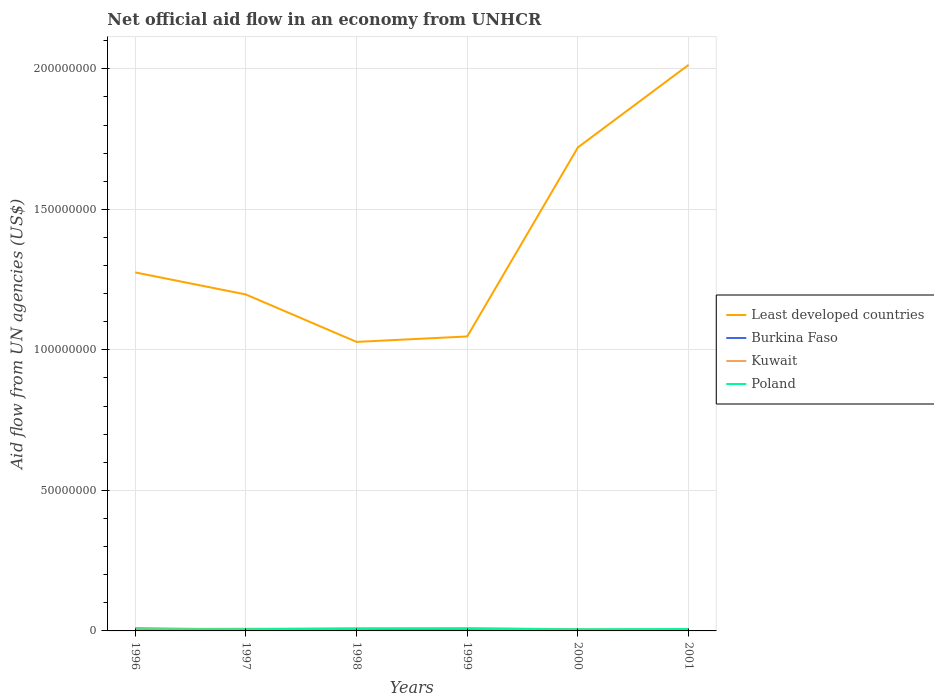Does the line corresponding to Least developed countries intersect with the line corresponding to Poland?
Provide a short and direct response. No. Across all years, what is the maximum net official aid flow in Kuwait?
Your response must be concise. 4.30e+05. In which year was the net official aid flow in Burkina Faso maximum?
Provide a succinct answer. 2000. What is the difference between the highest and the second highest net official aid flow in Kuwait?
Your answer should be very brief. 5.90e+05. What is the difference between the highest and the lowest net official aid flow in Burkina Faso?
Provide a short and direct response. 2. Is the net official aid flow in Kuwait strictly greater than the net official aid flow in Least developed countries over the years?
Give a very brief answer. Yes. How many lines are there?
Make the answer very short. 4. How many years are there in the graph?
Offer a terse response. 6. Does the graph contain any zero values?
Your answer should be very brief. No. Does the graph contain grids?
Provide a succinct answer. Yes. Where does the legend appear in the graph?
Your answer should be very brief. Center right. How are the legend labels stacked?
Offer a terse response. Vertical. What is the title of the graph?
Keep it short and to the point. Net official aid flow in an economy from UNHCR. Does "Syrian Arab Republic" appear as one of the legend labels in the graph?
Your answer should be very brief. No. What is the label or title of the X-axis?
Offer a terse response. Years. What is the label or title of the Y-axis?
Give a very brief answer. Aid flow from UN agencies (US$). What is the Aid flow from UN agencies (US$) in Least developed countries in 1996?
Your answer should be very brief. 1.28e+08. What is the Aid flow from UN agencies (US$) in Burkina Faso in 1996?
Make the answer very short. 9.00e+05. What is the Aid flow from UN agencies (US$) of Kuwait in 1996?
Provide a succinct answer. 6.90e+05. What is the Aid flow from UN agencies (US$) of Poland in 1996?
Offer a terse response. 5.40e+05. What is the Aid flow from UN agencies (US$) in Least developed countries in 1997?
Keep it short and to the point. 1.20e+08. What is the Aid flow from UN agencies (US$) in Burkina Faso in 1997?
Your response must be concise. 5.10e+05. What is the Aid flow from UN agencies (US$) in Kuwait in 1997?
Provide a succinct answer. 7.80e+05. What is the Aid flow from UN agencies (US$) in Poland in 1997?
Your answer should be very brief. 5.90e+05. What is the Aid flow from UN agencies (US$) in Least developed countries in 1998?
Keep it short and to the point. 1.03e+08. What is the Aid flow from UN agencies (US$) of Burkina Faso in 1998?
Your response must be concise. 3.80e+05. What is the Aid flow from UN agencies (US$) in Kuwait in 1998?
Give a very brief answer. 8.10e+05. What is the Aid flow from UN agencies (US$) in Poland in 1998?
Your answer should be compact. 9.20e+05. What is the Aid flow from UN agencies (US$) of Least developed countries in 1999?
Your answer should be compact. 1.05e+08. What is the Aid flow from UN agencies (US$) of Kuwait in 1999?
Your answer should be compact. 1.02e+06. What is the Aid flow from UN agencies (US$) of Poland in 1999?
Your response must be concise. 8.20e+05. What is the Aid flow from UN agencies (US$) in Least developed countries in 2000?
Ensure brevity in your answer.  1.72e+08. What is the Aid flow from UN agencies (US$) in Kuwait in 2000?
Provide a short and direct response. 5.80e+05. What is the Aid flow from UN agencies (US$) of Poland in 2000?
Your answer should be very brief. 5.70e+05. What is the Aid flow from UN agencies (US$) in Least developed countries in 2001?
Offer a terse response. 2.01e+08. What is the Aid flow from UN agencies (US$) in Kuwait in 2001?
Your answer should be very brief. 4.30e+05. What is the Aid flow from UN agencies (US$) in Poland in 2001?
Give a very brief answer. 6.80e+05. Across all years, what is the maximum Aid flow from UN agencies (US$) of Least developed countries?
Provide a short and direct response. 2.01e+08. Across all years, what is the maximum Aid flow from UN agencies (US$) in Kuwait?
Your answer should be very brief. 1.02e+06. Across all years, what is the maximum Aid flow from UN agencies (US$) in Poland?
Make the answer very short. 9.20e+05. Across all years, what is the minimum Aid flow from UN agencies (US$) in Least developed countries?
Your response must be concise. 1.03e+08. Across all years, what is the minimum Aid flow from UN agencies (US$) of Poland?
Make the answer very short. 5.40e+05. What is the total Aid flow from UN agencies (US$) of Least developed countries in the graph?
Your answer should be compact. 8.28e+08. What is the total Aid flow from UN agencies (US$) of Burkina Faso in the graph?
Your response must be concise. 2.54e+06. What is the total Aid flow from UN agencies (US$) of Kuwait in the graph?
Your answer should be very brief. 4.31e+06. What is the total Aid flow from UN agencies (US$) of Poland in the graph?
Make the answer very short. 4.12e+06. What is the difference between the Aid flow from UN agencies (US$) of Least developed countries in 1996 and that in 1997?
Your answer should be very brief. 7.85e+06. What is the difference between the Aid flow from UN agencies (US$) in Kuwait in 1996 and that in 1997?
Offer a very short reply. -9.00e+04. What is the difference between the Aid flow from UN agencies (US$) in Poland in 1996 and that in 1997?
Provide a succinct answer. -5.00e+04. What is the difference between the Aid flow from UN agencies (US$) in Least developed countries in 1996 and that in 1998?
Your response must be concise. 2.47e+07. What is the difference between the Aid flow from UN agencies (US$) in Burkina Faso in 1996 and that in 1998?
Ensure brevity in your answer.  5.20e+05. What is the difference between the Aid flow from UN agencies (US$) in Kuwait in 1996 and that in 1998?
Your response must be concise. -1.20e+05. What is the difference between the Aid flow from UN agencies (US$) of Poland in 1996 and that in 1998?
Make the answer very short. -3.80e+05. What is the difference between the Aid flow from UN agencies (US$) in Least developed countries in 1996 and that in 1999?
Offer a terse response. 2.28e+07. What is the difference between the Aid flow from UN agencies (US$) in Burkina Faso in 1996 and that in 1999?
Ensure brevity in your answer.  6.40e+05. What is the difference between the Aid flow from UN agencies (US$) of Kuwait in 1996 and that in 1999?
Provide a short and direct response. -3.30e+05. What is the difference between the Aid flow from UN agencies (US$) in Poland in 1996 and that in 1999?
Provide a succinct answer. -2.80e+05. What is the difference between the Aid flow from UN agencies (US$) in Least developed countries in 1996 and that in 2000?
Provide a short and direct response. -4.45e+07. What is the difference between the Aid flow from UN agencies (US$) in Burkina Faso in 1996 and that in 2000?
Make the answer very short. 7.00e+05. What is the difference between the Aid flow from UN agencies (US$) in Kuwait in 1996 and that in 2000?
Your answer should be compact. 1.10e+05. What is the difference between the Aid flow from UN agencies (US$) of Poland in 1996 and that in 2000?
Offer a very short reply. -3.00e+04. What is the difference between the Aid flow from UN agencies (US$) of Least developed countries in 1996 and that in 2001?
Provide a short and direct response. -7.38e+07. What is the difference between the Aid flow from UN agencies (US$) of Burkina Faso in 1996 and that in 2001?
Your response must be concise. 6.10e+05. What is the difference between the Aid flow from UN agencies (US$) of Least developed countries in 1997 and that in 1998?
Your answer should be compact. 1.69e+07. What is the difference between the Aid flow from UN agencies (US$) in Burkina Faso in 1997 and that in 1998?
Provide a succinct answer. 1.30e+05. What is the difference between the Aid flow from UN agencies (US$) in Poland in 1997 and that in 1998?
Offer a terse response. -3.30e+05. What is the difference between the Aid flow from UN agencies (US$) of Least developed countries in 1997 and that in 1999?
Your answer should be compact. 1.49e+07. What is the difference between the Aid flow from UN agencies (US$) of Burkina Faso in 1997 and that in 1999?
Offer a terse response. 2.50e+05. What is the difference between the Aid flow from UN agencies (US$) in Least developed countries in 1997 and that in 2000?
Your response must be concise. -5.23e+07. What is the difference between the Aid flow from UN agencies (US$) in Kuwait in 1997 and that in 2000?
Offer a very short reply. 2.00e+05. What is the difference between the Aid flow from UN agencies (US$) of Poland in 1997 and that in 2000?
Your response must be concise. 2.00e+04. What is the difference between the Aid flow from UN agencies (US$) in Least developed countries in 1997 and that in 2001?
Your answer should be very brief. -8.17e+07. What is the difference between the Aid flow from UN agencies (US$) in Poland in 1997 and that in 2001?
Ensure brevity in your answer.  -9.00e+04. What is the difference between the Aid flow from UN agencies (US$) in Least developed countries in 1998 and that in 1999?
Ensure brevity in your answer.  -1.93e+06. What is the difference between the Aid flow from UN agencies (US$) of Least developed countries in 1998 and that in 2000?
Provide a succinct answer. -6.92e+07. What is the difference between the Aid flow from UN agencies (US$) of Burkina Faso in 1998 and that in 2000?
Your answer should be very brief. 1.80e+05. What is the difference between the Aid flow from UN agencies (US$) in Poland in 1998 and that in 2000?
Ensure brevity in your answer.  3.50e+05. What is the difference between the Aid flow from UN agencies (US$) of Least developed countries in 1998 and that in 2001?
Offer a terse response. -9.86e+07. What is the difference between the Aid flow from UN agencies (US$) of Least developed countries in 1999 and that in 2000?
Offer a terse response. -6.73e+07. What is the difference between the Aid flow from UN agencies (US$) in Least developed countries in 1999 and that in 2001?
Your response must be concise. -9.66e+07. What is the difference between the Aid flow from UN agencies (US$) of Kuwait in 1999 and that in 2001?
Provide a short and direct response. 5.90e+05. What is the difference between the Aid flow from UN agencies (US$) of Poland in 1999 and that in 2001?
Keep it short and to the point. 1.40e+05. What is the difference between the Aid flow from UN agencies (US$) of Least developed countries in 2000 and that in 2001?
Your response must be concise. -2.94e+07. What is the difference between the Aid flow from UN agencies (US$) of Burkina Faso in 2000 and that in 2001?
Offer a very short reply. -9.00e+04. What is the difference between the Aid flow from UN agencies (US$) of Kuwait in 2000 and that in 2001?
Ensure brevity in your answer.  1.50e+05. What is the difference between the Aid flow from UN agencies (US$) in Poland in 2000 and that in 2001?
Ensure brevity in your answer.  -1.10e+05. What is the difference between the Aid flow from UN agencies (US$) of Least developed countries in 1996 and the Aid flow from UN agencies (US$) of Burkina Faso in 1997?
Make the answer very short. 1.27e+08. What is the difference between the Aid flow from UN agencies (US$) in Least developed countries in 1996 and the Aid flow from UN agencies (US$) in Kuwait in 1997?
Your answer should be compact. 1.27e+08. What is the difference between the Aid flow from UN agencies (US$) in Least developed countries in 1996 and the Aid flow from UN agencies (US$) in Poland in 1997?
Offer a terse response. 1.27e+08. What is the difference between the Aid flow from UN agencies (US$) in Burkina Faso in 1996 and the Aid flow from UN agencies (US$) in Kuwait in 1997?
Keep it short and to the point. 1.20e+05. What is the difference between the Aid flow from UN agencies (US$) in Burkina Faso in 1996 and the Aid flow from UN agencies (US$) in Poland in 1997?
Provide a succinct answer. 3.10e+05. What is the difference between the Aid flow from UN agencies (US$) in Least developed countries in 1996 and the Aid flow from UN agencies (US$) in Burkina Faso in 1998?
Provide a short and direct response. 1.27e+08. What is the difference between the Aid flow from UN agencies (US$) of Least developed countries in 1996 and the Aid flow from UN agencies (US$) of Kuwait in 1998?
Your answer should be compact. 1.27e+08. What is the difference between the Aid flow from UN agencies (US$) of Least developed countries in 1996 and the Aid flow from UN agencies (US$) of Poland in 1998?
Your answer should be very brief. 1.27e+08. What is the difference between the Aid flow from UN agencies (US$) in Burkina Faso in 1996 and the Aid flow from UN agencies (US$) in Kuwait in 1998?
Give a very brief answer. 9.00e+04. What is the difference between the Aid flow from UN agencies (US$) in Kuwait in 1996 and the Aid flow from UN agencies (US$) in Poland in 1998?
Provide a short and direct response. -2.30e+05. What is the difference between the Aid flow from UN agencies (US$) of Least developed countries in 1996 and the Aid flow from UN agencies (US$) of Burkina Faso in 1999?
Provide a succinct answer. 1.27e+08. What is the difference between the Aid flow from UN agencies (US$) in Least developed countries in 1996 and the Aid flow from UN agencies (US$) in Kuwait in 1999?
Keep it short and to the point. 1.27e+08. What is the difference between the Aid flow from UN agencies (US$) in Least developed countries in 1996 and the Aid flow from UN agencies (US$) in Poland in 1999?
Your answer should be compact. 1.27e+08. What is the difference between the Aid flow from UN agencies (US$) of Burkina Faso in 1996 and the Aid flow from UN agencies (US$) of Kuwait in 1999?
Offer a terse response. -1.20e+05. What is the difference between the Aid flow from UN agencies (US$) in Least developed countries in 1996 and the Aid flow from UN agencies (US$) in Burkina Faso in 2000?
Provide a succinct answer. 1.27e+08. What is the difference between the Aid flow from UN agencies (US$) of Least developed countries in 1996 and the Aid flow from UN agencies (US$) of Kuwait in 2000?
Provide a short and direct response. 1.27e+08. What is the difference between the Aid flow from UN agencies (US$) of Least developed countries in 1996 and the Aid flow from UN agencies (US$) of Poland in 2000?
Offer a terse response. 1.27e+08. What is the difference between the Aid flow from UN agencies (US$) of Burkina Faso in 1996 and the Aid flow from UN agencies (US$) of Kuwait in 2000?
Provide a succinct answer. 3.20e+05. What is the difference between the Aid flow from UN agencies (US$) in Burkina Faso in 1996 and the Aid flow from UN agencies (US$) in Poland in 2000?
Provide a short and direct response. 3.30e+05. What is the difference between the Aid flow from UN agencies (US$) of Least developed countries in 1996 and the Aid flow from UN agencies (US$) of Burkina Faso in 2001?
Your answer should be compact. 1.27e+08. What is the difference between the Aid flow from UN agencies (US$) of Least developed countries in 1996 and the Aid flow from UN agencies (US$) of Kuwait in 2001?
Make the answer very short. 1.27e+08. What is the difference between the Aid flow from UN agencies (US$) in Least developed countries in 1996 and the Aid flow from UN agencies (US$) in Poland in 2001?
Ensure brevity in your answer.  1.27e+08. What is the difference between the Aid flow from UN agencies (US$) in Least developed countries in 1997 and the Aid flow from UN agencies (US$) in Burkina Faso in 1998?
Your answer should be very brief. 1.19e+08. What is the difference between the Aid flow from UN agencies (US$) of Least developed countries in 1997 and the Aid flow from UN agencies (US$) of Kuwait in 1998?
Provide a short and direct response. 1.19e+08. What is the difference between the Aid flow from UN agencies (US$) of Least developed countries in 1997 and the Aid flow from UN agencies (US$) of Poland in 1998?
Offer a very short reply. 1.19e+08. What is the difference between the Aid flow from UN agencies (US$) of Burkina Faso in 1997 and the Aid flow from UN agencies (US$) of Poland in 1998?
Provide a short and direct response. -4.10e+05. What is the difference between the Aid flow from UN agencies (US$) in Least developed countries in 1997 and the Aid flow from UN agencies (US$) in Burkina Faso in 1999?
Provide a short and direct response. 1.19e+08. What is the difference between the Aid flow from UN agencies (US$) in Least developed countries in 1997 and the Aid flow from UN agencies (US$) in Kuwait in 1999?
Make the answer very short. 1.19e+08. What is the difference between the Aid flow from UN agencies (US$) of Least developed countries in 1997 and the Aid flow from UN agencies (US$) of Poland in 1999?
Provide a succinct answer. 1.19e+08. What is the difference between the Aid flow from UN agencies (US$) in Burkina Faso in 1997 and the Aid flow from UN agencies (US$) in Kuwait in 1999?
Make the answer very short. -5.10e+05. What is the difference between the Aid flow from UN agencies (US$) in Burkina Faso in 1997 and the Aid flow from UN agencies (US$) in Poland in 1999?
Offer a very short reply. -3.10e+05. What is the difference between the Aid flow from UN agencies (US$) of Kuwait in 1997 and the Aid flow from UN agencies (US$) of Poland in 1999?
Provide a succinct answer. -4.00e+04. What is the difference between the Aid flow from UN agencies (US$) in Least developed countries in 1997 and the Aid flow from UN agencies (US$) in Burkina Faso in 2000?
Provide a succinct answer. 1.20e+08. What is the difference between the Aid flow from UN agencies (US$) of Least developed countries in 1997 and the Aid flow from UN agencies (US$) of Kuwait in 2000?
Offer a very short reply. 1.19e+08. What is the difference between the Aid flow from UN agencies (US$) in Least developed countries in 1997 and the Aid flow from UN agencies (US$) in Poland in 2000?
Keep it short and to the point. 1.19e+08. What is the difference between the Aid flow from UN agencies (US$) in Least developed countries in 1997 and the Aid flow from UN agencies (US$) in Burkina Faso in 2001?
Offer a very short reply. 1.19e+08. What is the difference between the Aid flow from UN agencies (US$) in Least developed countries in 1997 and the Aid flow from UN agencies (US$) in Kuwait in 2001?
Ensure brevity in your answer.  1.19e+08. What is the difference between the Aid flow from UN agencies (US$) in Least developed countries in 1997 and the Aid flow from UN agencies (US$) in Poland in 2001?
Provide a short and direct response. 1.19e+08. What is the difference between the Aid flow from UN agencies (US$) in Burkina Faso in 1997 and the Aid flow from UN agencies (US$) in Kuwait in 2001?
Ensure brevity in your answer.  8.00e+04. What is the difference between the Aid flow from UN agencies (US$) in Least developed countries in 1998 and the Aid flow from UN agencies (US$) in Burkina Faso in 1999?
Provide a short and direct response. 1.03e+08. What is the difference between the Aid flow from UN agencies (US$) of Least developed countries in 1998 and the Aid flow from UN agencies (US$) of Kuwait in 1999?
Offer a very short reply. 1.02e+08. What is the difference between the Aid flow from UN agencies (US$) of Least developed countries in 1998 and the Aid flow from UN agencies (US$) of Poland in 1999?
Ensure brevity in your answer.  1.02e+08. What is the difference between the Aid flow from UN agencies (US$) in Burkina Faso in 1998 and the Aid flow from UN agencies (US$) in Kuwait in 1999?
Offer a terse response. -6.40e+05. What is the difference between the Aid flow from UN agencies (US$) in Burkina Faso in 1998 and the Aid flow from UN agencies (US$) in Poland in 1999?
Give a very brief answer. -4.40e+05. What is the difference between the Aid flow from UN agencies (US$) in Least developed countries in 1998 and the Aid flow from UN agencies (US$) in Burkina Faso in 2000?
Provide a short and direct response. 1.03e+08. What is the difference between the Aid flow from UN agencies (US$) in Least developed countries in 1998 and the Aid flow from UN agencies (US$) in Kuwait in 2000?
Your answer should be compact. 1.02e+08. What is the difference between the Aid flow from UN agencies (US$) in Least developed countries in 1998 and the Aid flow from UN agencies (US$) in Poland in 2000?
Provide a short and direct response. 1.02e+08. What is the difference between the Aid flow from UN agencies (US$) in Burkina Faso in 1998 and the Aid flow from UN agencies (US$) in Kuwait in 2000?
Your response must be concise. -2.00e+05. What is the difference between the Aid flow from UN agencies (US$) of Kuwait in 1998 and the Aid flow from UN agencies (US$) of Poland in 2000?
Offer a terse response. 2.40e+05. What is the difference between the Aid flow from UN agencies (US$) in Least developed countries in 1998 and the Aid flow from UN agencies (US$) in Burkina Faso in 2001?
Offer a terse response. 1.03e+08. What is the difference between the Aid flow from UN agencies (US$) in Least developed countries in 1998 and the Aid flow from UN agencies (US$) in Kuwait in 2001?
Your response must be concise. 1.02e+08. What is the difference between the Aid flow from UN agencies (US$) in Least developed countries in 1998 and the Aid flow from UN agencies (US$) in Poland in 2001?
Ensure brevity in your answer.  1.02e+08. What is the difference between the Aid flow from UN agencies (US$) in Least developed countries in 1999 and the Aid flow from UN agencies (US$) in Burkina Faso in 2000?
Ensure brevity in your answer.  1.05e+08. What is the difference between the Aid flow from UN agencies (US$) in Least developed countries in 1999 and the Aid flow from UN agencies (US$) in Kuwait in 2000?
Keep it short and to the point. 1.04e+08. What is the difference between the Aid flow from UN agencies (US$) of Least developed countries in 1999 and the Aid flow from UN agencies (US$) of Poland in 2000?
Give a very brief answer. 1.04e+08. What is the difference between the Aid flow from UN agencies (US$) of Burkina Faso in 1999 and the Aid flow from UN agencies (US$) of Kuwait in 2000?
Your answer should be very brief. -3.20e+05. What is the difference between the Aid flow from UN agencies (US$) in Burkina Faso in 1999 and the Aid flow from UN agencies (US$) in Poland in 2000?
Your answer should be compact. -3.10e+05. What is the difference between the Aid flow from UN agencies (US$) in Least developed countries in 1999 and the Aid flow from UN agencies (US$) in Burkina Faso in 2001?
Offer a terse response. 1.04e+08. What is the difference between the Aid flow from UN agencies (US$) of Least developed countries in 1999 and the Aid flow from UN agencies (US$) of Kuwait in 2001?
Your answer should be compact. 1.04e+08. What is the difference between the Aid flow from UN agencies (US$) of Least developed countries in 1999 and the Aid flow from UN agencies (US$) of Poland in 2001?
Offer a very short reply. 1.04e+08. What is the difference between the Aid flow from UN agencies (US$) of Burkina Faso in 1999 and the Aid flow from UN agencies (US$) of Kuwait in 2001?
Your response must be concise. -1.70e+05. What is the difference between the Aid flow from UN agencies (US$) in Burkina Faso in 1999 and the Aid flow from UN agencies (US$) in Poland in 2001?
Ensure brevity in your answer.  -4.20e+05. What is the difference between the Aid flow from UN agencies (US$) in Least developed countries in 2000 and the Aid flow from UN agencies (US$) in Burkina Faso in 2001?
Your response must be concise. 1.72e+08. What is the difference between the Aid flow from UN agencies (US$) in Least developed countries in 2000 and the Aid flow from UN agencies (US$) in Kuwait in 2001?
Your answer should be very brief. 1.72e+08. What is the difference between the Aid flow from UN agencies (US$) in Least developed countries in 2000 and the Aid flow from UN agencies (US$) in Poland in 2001?
Offer a terse response. 1.71e+08. What is the difference between the Aid flow from UN agencies (US$) in Burkina Faso in 2000 and the Aid flow from UN agencies (US$) in Poland in 2001?
Provide a short and direct response. -4.80e+05. What is the average Aid flow from UN agencies (US$) of Least developed countries per year?
Your answer should be very brief. 1.38e+08. What is the average Aid flow from UN agencies (US$) of Burkina Faso per year?
Your answer should be compact. 4.23e+05. What is the average Aid flow from UN agencies (US$) of Kuwait per year?
Provide a succinct answer. 7.18e+05. What is the average Aid flow from UN agencies (US$) in Poland per year?
Give a very brief answer. 6.87e+05. In the year 1996, what is the difference between the Aid flow from UN agencies (US$) in Least developed countries and Aid flow from UN agencies (US$) in Burkina Faso?
Make the answer very short. 1.27e+08. In the year 1996, what is the difference between the Aid flow from UN agencies (US$) in Least developed countries and Aid flow from UN agencies (US$) in Kuwait?
Keep it short and to the point. 1.27e+08. In the year 1996, what is the difference between the Aid flow from UN agencies (US$) in Least developed countries and Aid flow from UN agencies (US$) in Poland?
Provide a succinct answer. 1.27e+08. In the year 1997, what is the difference between the Aid flow from UN agencies (US$) in Least developed countries and Aid flow from UN agencies (US$) in Burkina Faso?
Your response must be concise. 1.19e+08. In the year 1997, what is the difference between the Aid flow from UN agencies (US$) of Least developed countries and Aid flow from UN agencies (US$) of Kuwait?
Offer a very short reply. 1.19e+08. In the year 1997, what is the difference between the Aid flow from UN agencies (US$) of Least developed countries and Aid flow from UN agencies (US$) of Poland?
Give a very brief answer. 1.19e+08. In the year 1998, what is the difference between the Aid flow from UN agencies (US$) of Least developed countries and Aid flow from UN agencies (US$) of Burkina Faso?
Provide a short and direct response. 1.02e+08. In the year 1998, what is the difference between the Aid flow from UN agencies (US$) in Least developed countries and Aid flow from UN agencies (US$) in Kuwait?
Provide a succinct answer. 1.02e+08. In the year 1998, what is the difference between the Aid flow from UN agencies (US$) in Least developed countries and Aid flow from UN agencies (US$) in Poland?
Make the answer very short. 1.02e+08. In the year 1998, what is the difference between the Aid flow from UN agencies (US$) in Burkina Faso and Aid flow from UN agencies (US$) in Kuwait?
Offer a very short reply. -4.30e+05. In the year 1998, what is the difference between the Aid flow from UN agencies (US$) in Burkina Faso and Aid flow from UN agencies (US$) in Poland?
Your response must be concise. -5.40e+05. In the year 1999, what is the difference between the Aid flow from UN agencies (US$) in Least developed countries and Aid flow from UN agencies (US$) in Burkina Faso?
Offer a terse response. 1.05e+08. In the year 1999, what is the difference between the Aid flow from UN agencies (US$) in Least developed countries and Aid flow from UN agencies (US$) in Kuwait?
Give a very brief answer. 1.04e+08. In the year 1999, what is the difference between the Aid flow from UN agencies (US$) in Least developed countries and Aid flow from UN agencies (US$) in Poland?
Offer a very short reply. 1.04e+08. In the year 1999, what is the difference between the Aid flow from UN agencies (US$) of Burkina Faso and Aid flow from UN agencies (US$) of Kuwait?
Offer a terse response. -7.60e+05. In the year 1999, what is the difference between the Aid flow from UN agencies (US$) of Burkina Faso and Aid flow from UN agencies (US$) of Poland?
Ensure brevity in your answer.  -5.60e+05. In the year 1999, what is the difference between the Aid flow from UN agencies (US$) of Kuwait and Aid flow from UN agencies (US$) of Poland?
Your response must be concise. 2.00e+05. In the year 2000, what is the difference between the Aid flow from UN agencies (US$) in Least developed countries and Aid flow from UN agencies (US$) in Burkina Faso?
Offer a very short reply. 1.72e+08. In the year 2000, what is the difference between the Aid flow from UN agencies (US$) in Least developed countries and Aid flow from UN agencies (US$) in Kuwait?
Offer a terse response. 1.71e+08. In the year 2000, what is the difference between the Aid flow from UN agencies (US$) of Least developed countries and Aid flow from UN agencies (US$) of Poland?
Give a very brief answer. 1.71e+08. In the year 2000, what is the difference between the Aid flow from UN agencies (US$) of Burkina Faso and Aid flow from UN agencies (US$) of Kuwait?
Make the answer very short. -3.80e+05. In the year 2000, what is the difference between the Aid flow from UN agencies (US$) in Burkina Faso and Aid flow from UN agencies (US$) in Poland?
Your response must be concise. -3.70e+05. In the year 2001, what is the difference between the Aid flow from UN agencies (US$) of Least developed countries and Aid flow from UN agencies (US$) of Burkina Faso?
Your answer should be very brief. 2.01e+08. In the year 2001, what is the difference between the Aid flow from UN agencies (US$) in Least developed countries and Aid flow from UN agencies (US$) in Kuwait?
Keep it short and to the point. 2.01e+08. In the year 2001, what is the difference between the Aid flow from UN agencies (US$) of Least developed countries and Aid flow from UN agencies (US$) of Poland?
Offer a very short reply. 2.01e+08. In the year 2001, what is the difference between the Aid flow from UN agencies (US$) in Burkina Faso and Aid flow from UN agencies (US$) in Poland?
Your answer should be very brief. -3.90e+05. In the year 2001, what is the difference between the Aid flow from UN agencies (US$) of Kuwait and Aid flow from UN agencies (US$) of Poland?
Provide a short and direct response. -2.50e+05. What is the ratio of the Aid flow from UN agencies (US$) of Least developed countries in 1996 to that in 1997?
Provide a short and direct response. 1.07. What is the ratio of the Aid flow from UN agencies (US$) of Burkina Faso in 1996 to that in 1997?
Provide a succinct answer. 1.76. What is the ratio of the Aid flow from UN agencies (US$) of Kuwait in 1996 to that in 1997?
Make the answer very short. 0.88. What is the ratio of the Aid flow from UN agencies (US$) of Poland in 1996 to that in 1997?
Offer a very short reply. 0.92. What is the ratio of the Aid flow from UN agencies (US$) of Least developed countries in 1996 to that in 1998?
Keep it short and to the point. 1.24. What is the ratio of the Aid flow from UN agencies (US$) of Burkina Faso in 1996 to that in 1998?
Offer a very short reply. 2.37. What is the ratio of the Aid flow from UN agencies (US$) of Kuwait in 1996 to that in 1998?
Offer a terse response. 0.85. What is the ratio of the Aid flow from UN agencies (US$) of Poland in 1996 to that in 1998?
Make the answer very short. 0.59. What is the ratio of the Aid flow from UN agencies (US$) in Least developed countries in 1996 to that in 1999?
Your answer should be very brief. 1.22. What is the ratio of the Aid flow from UN agencies (US$) of Burkina Faso in 1996 to that in 1999?
Provide a short and direct response. 3.46. What is the ratio of the Aid flow from UN agencies (US$) of Kuwait in 1996 to that in 1999?
Provide a short and direct response. 0.68. What is the ratio of the Aid flow from UN agencies (US$) of Poland in 1996 to that in 1999?
Provide a succinct answer. 0.66. What is the ratio of the Aid flow from UN agencies (US$) of Least developed countries in 1996 to that in 2000?
Keep it short and to the point. 0.74. What is the ratio of the Aid flow from UN agencies (US$) of Burkina Faso in 1996 to that in 2000?
Offer a very short reply. 4.5. What is the ratio of the Aid flow from UN agencies (US$) of Kuwait in 1996 to that in 2000?
Provide a short and direct response. 1.19. What is the ratio of the Aid flow from UN agencies (US$) of Least developed countries in 1996 to that in 2001?
Offer a very short reply. 0.63. What is the ratio of the Aid flow from UN agencies (US$) in Burkina Faso in 1996 to that in 2001?
Offer a terse response. 3.1. What is the ratio of the Aid flow from UN agencies (US$) of Kuwait in 1996 to that in 2001?
Provide a short and direct response. 1.6. What is the ratio of the Aid flow from UN agencies (US$) in Poland in 1996 to that in 2001?
Offer a very short reply. 0.79. What is the ratio of the Aid flow from UN agencies (US$) in Least developed countries in 1997 to that in 1998?
Make the answer very short. 1.16. What is the ratio of the Aid flow from UN agencies (US$) in Burkina Faso in 1997 to that in 1998?
Give a very brief answer. 1.34. What is the ratio of the Aid flow from UN agencies (US$) in Kuwait in 1997 to that in 1998?
Your response must be concise. 0.96. What is the ratio of the Aid flow from UN agencies (US$) in Poland in 1997 to that in 1998?
Your answer should be compact. 0.64. What is the ratio of the Aid flow from UN agencies (US$) of Least developed countries in 1997 to that in 1999?
Your answer should be compact. 1.14. What is the ratio of the Aid flow from UN agencies (US$) of Burkina Faso in 1997 to that in 1999?
Offer a terse response. 1.96. What is the ratio of the Aid flow from UN agencies (US$) in Kuwait in 1997 to that in 1999?
Offer a very short reply. 0.76. What is the ratio of the Aid flow from UN agencies (US$) of Poland in 1997 to that in 1999?
Provide a succinct answer. 0.72. What is the ratio of the Aid flow from UN agencies (US$) of Least developed countries in 1997 to that in 2000?
Provide a short and direct response. 0.7. What is the ratio of the Aid flow from UN agencies (US$) of Burkina Faso in 1997 to that in 2000?
Keep it short and to the point. 2.55. What is the ratio of the Aid flow from UN agencies (US$) of Kuwait in 1997 to that in 2000?
Give a very brief answer. 1.34. What is the ratio of the Aid flow from UN agencies (US$) in Poland in 1997 to that in 2000?
Your answer should be compact. 1.04. What is the ratio of the Aid flow from UN agencies (US$) in Least developed countries in 1997 to that in 2001?
Keep it short and to the point. 0.59. What is the ratio of the Aid flow from UN agencies (US$) in Burkina Faso in 1997 to that in 2001?
Offer a very short reply. 1.76. What is the ratio of the Aid flow from UN agencies (US$) in Kuwait in 1997 to that in 2001?
Give a very brief answer. 1.81. What is the ratio of the Aid flow from UN agencies (US$) of Poland in 1997 to that in 2001?
Ensure brevity in your answer.  0.87. What is the ratio of the Aid flow from UN agencies (US$) in Least developed countries in 1998 to that in 1999?
Give a very brief answer. 0.98. What is the ratio of the Aid flow from UN agencies (US$) in Burkina Faso in 1998 to that in 1999?
Give a very brief answer. 1.46. What is the ratio of the Aid flow from UN agencies (US$) of Kuwait in 1998 to that in 1999?
Your answer should be very brief. 0.79. What is the ratio of the Aid flow from UN agencies (US$) in Poland in 1998 to that in 1999?
Give a very brief answer. 1.12. What is the ratio of the Aid flow from UN agencies (US$) in Least developed countries in 1998 to that in 2000?
Make the answer very short. 0.6. What is the ratio of the Aid flow from UN agencies (US$) of Kuwait in 1998 to that in 2000?
Keep it short and to the point. 1.4. What is the ratio of the Aid flow from UN agencies (US$) of Poland in 1998 to that in 2000?
Give a very brief answer. 1.61. What is the ratio of the Aid flow from UN agencies (US$) in Least developed countries in 1998 to that in 2001?
Your response must be concise. 0.51. What is the ratio of the Aid flow from UN agencies (US$) of Burkina Faso in 1998 to that in 2001?
Your answer should be compact. 1.31. What is the ratio of the Aid flow from UN agencies (US$) of Kuwait in 1998 to that in 2001?
Offer a very short reply. 1.88. What is the ratio of the Aid flow from UN agencies (US$) of Poland in 1998 to that in 2001?
Offer a terse response. 1.35. What is the ratio of the Aid flow from UN agencies (US$) in Least developed countries in 1999 to that in 2000?
Make the answer very short. 0.61. What is the ratio of the Aid flow from UN agencies (US$) in Burkina Faso in 1999 to that in 2000?
Your response must be concise. 1.3. What is the ratio of the Aid flow from UN agencies (US$) of Kuwait in 1999 to that in 2000?
Provide a short and direct response. 1.76. What is the ratio of the Aid flow from UN agencies (US$) of Poland in 1999 to that in 2000?
Provide a short and direct response. 1.44. What is the ratio of the Aid flow from UN agencies (US$) of Least developed countries in 1999 to that in 2001?
Make the answer very short. 0.52. What is the ratio of the Aid flow from UN agencies (US$) in Burkina Faso in 1999 to that in 2001?
Keep it short and to the point. 0.9. What is the ratio of the Aid flow from UN agencies (US$) of Kuwait in 1999 to that in 2001?
Your answer should be very brief. 2.37. What is the ratio of the Aid flow from UN agencies (US$) in Poland in 1999 to that in 2001?
Your answer should be compact. 1.21. What is the ratio of the Aid flow from UN agencies (US$) of Least developed countries in 2000 to that in 2001?
Ensure brevity in your answer.  0.85. What is the ratio of the Aid flow from UN agencies (US$) of Burkina Faso in 2000 to that in 2001?
Ensure brevity in your answer.  0.69. What is the ratio of the Aid flow from UN agencies (US$) of Kuwait in 2000 to that in 2001?
Your answer should be very brief. 1.35. What is the ratio of the Aid flow from UN agencies (US$) in Poland in 2000 to that in 2001?
Your answer should be very brief. 0.84. What is the difference between the highest and the second highest Aid flow from UN agencies (US$) in Least developed countries?
Ensure brevity in your answer.  2.94e+07. What is the difference between the highest and the second highest Aid flow from UN agencies (US$) of Kuwait?
Keep it short and to the point. 2.10e+05. What is the difference between the highest and the second highest Aid flow from UN agencies (US$) in Poland?
Provide a succinct answer. 1.00e+05. What is the difference between the highest and the lowest Aid flow from UN agencies (US$) in Least developed countries?
Ensure brevity in your answer.  9.86e+07. What is the difference between the highest and the lowest Aid flow from UN agencies (US$) of Burkina Faso?
Your response must be concise. 7.00e+05. What is the difference between the highest and the lowest Aid flow from UN agencies (US$) in Kuwait?
Your response must be concise. 5.90e+05. 